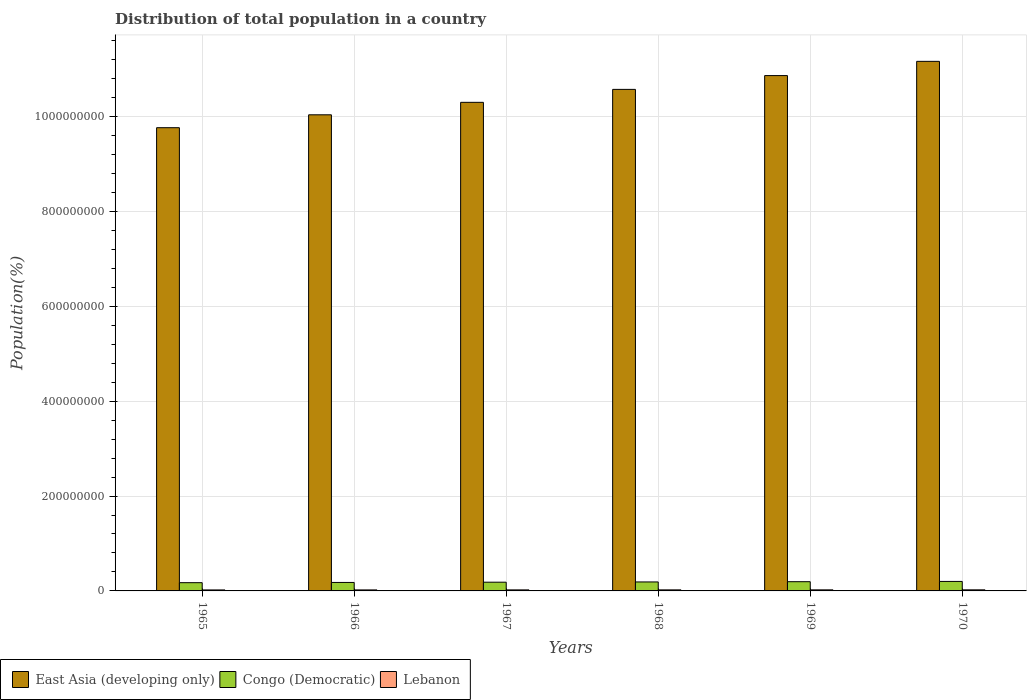How many different coloured bars are there?
Your response must be concise. 3. How many groups of bars are there?
Your answer should be very brief. 6. How many bars are there on the 6th tick from the right?
Your answer should be compact. 3. What is the label of the 4th group of bars from the left?
Give a very brief answer. 1968. In how many cases, is the number of bars for a given year not equal to the number of legend labels?
Provide a succinct answer. 0. What is the population of in Lebanon in 1966?
Your answer should be very brief. 2.14e+06. Across all years, what is the maximum population of in East Asia (developing only)?
Offer a terse response. 1.12e+09. Across all years, what is the minimum population of in Lebanon?
Your answer should be very brief. 2.09e+06. In which year was the population of in East Asia (developing only) minimum?
Your answer should be very brief. 1965. What is the total population of in Congo (Democratic) in the graph?
Ensure brevity in your answer.  1.12e+08. What is the difference between the population of in Congo (Democratic) in 1965 and that in 1967?
Offer a very short reply. -1.01e+06. What is the difference between the population of in Lebanon in 1966 and the population of in Congo (Democratic) in 1970?
Offer a terse response. -1.79e+07. What is the average population of in Lebanon per year?
Your answer should be very brief. 2.19e+06. In the year 1967, what is the difference between the population of in Lebanon and population of in Congo (Democratic)?
Your answer should be compact. -1.62e+07. What is the ratio of the population of in Congo (Democratic) in 1965 to that in 1967?
Offer a terse response. 0.95. What is the difference between the highest and the second highest population of in Congo (Democratic)?
Offer a terse response. 5.51e+05. What is the difference between the highest and the lowest population of in East Asia (developing only)?
Keep it short and to the point. 1.40e+08. In how many years, is the population of in East Asia (developing only) greater than the average population of in East Asia (developing only) taken over all years?
Provide a short and direct response. 3. What does the 2nd bar from the left in 1966 represents?
Your response must be concise. Congo (Democratic). What does the 1st bar from the right in 1967 represents?
Your answer should be compact. Lebanon. Are all the bars in the graph horizontal?
Make the answer very short. No. How many years are there in the graph?
Make the answer very short. 6. What is the difference between two consecutive major ticks on the Y-axis?
Your response must be concise. 2.00e+08. Does the graph contain any zero values?
Keep it short and to the point. No. Where does the legend appear in the graph?
Give a very brief answer. Bottom left. What is the title of the graph?
Your answer should be very brief. Distribution of total population in a country. What is the label or title of the X-axis?
Your response must be concise. Years. What is the label or title of the Y-axis?
Keep it short and to the point. Population(%). What is the Population(%) of East Asia (developing only) in 1965?
Provide a short and direct response. 9.76e+08. What is the Population(%) in Congo (Democratic) in 1965?
Ensure brevity in your answer.  1.74e+07. What is the Population(%) of Lebanon in 1965?
Your response must be concise. 2.09e+06. What is the Population(%) of East Asia (developing only) in 1966?
Offer a terse response. 1.00e+09. What is the Population(%) of Congo (Democratic) in 1966?
Ensure brevity in your answer.  1.79e+07. What is the Population(%) of Lebanon in 1966?
Give a very brief answer. 2.14e+06. What is the Population(%) of East Asia (developing only) in 1967?
Your answer should be very brief. 1.03e+09. What is the Population(%) of Congo (Democratic) in 1967?
Your answer should be very brief. 1.84e+07. What is the Population(%) of Lebanon in 1967?
Your answer should be very brief. 2.17e+06. What is the Population(%) of East Asia (developing only) in 1968?
Provide a short and direct response. 1.06e+09. What is the Population(%) of Congo (Democratic) in 1968?
Your response must be concise. 1.89e+07. What is the Population(%) of Lebanon in 1968?
Your answer should be compact. 2.21e+06. What is the Population(%) in East Asia (developing only) in 1969?
Provide a succinct answer. 1.09e+09. What is the Population(%) of Congo (Democratic) in 1969?
Offer a terse response. 1.95e+07. What is the Population(%) in Lebanon in 1969?
Your response must be concise. 2.25e+06. What is the Population(%) in East Asia (developing only) in 1970?
Ensure brevity in your answer.  1.12e+09. What is the Population(%) of Congo (Democratic) in 1970?
Provide a succinct answer. 2.00e+07. What is the Population(%) of Lebanon in 1970?
Keep it short and to the point. 2.30e+06. Across all years, what is the maximum Population(%) of East Asia (developing only)?
Provide a short and direct response. 1.12e+09. Across all years, what is the maximum Population(%) in Congo (Democratic)?
Offer a terse response. 2.00e+07. Across all years, what is the maximum Population(%) in Lebanon?
Provide a short and direct response. 2.30e+06. Across all years, what is the minimum Population(%) of East Asia (developing only)?
Ensure brevity in your answer.  9.76e+08. Across all years, what is the minimum Population(%) of Congo (Democratic)?
Ensure brevity in your answer.  1.74e+07. Across all years, what is the minimum Population(%) in Lebanon?
Offer a very short reply. 2.09e+06. What is the total Population(%) of East Asia (developing only) in the graph?
Your answer should be very brief. 6.27e+09. What is the total Population(%) of Congo (Democratic) in the graph?
Make the answer very short. 1.12e+08. What is the total Population(%) in Lebanon in the graph?
Your response must be concise. 1.32e+07. What is the difference between the Population(%) in East Asia (developing only) in 1965 and that in 1966?
Make the answer very short. -2.72e+07. What is the difference between the Population(%) in Congo (Democratic) in 1965 and that in 1966?
Make the answer very short. -4.92e+05. What is the difference between the Population(%) in Lebanon in 1965 and that in 1966?
Your answer should be compact. -4.43e+04. What is the difference between the Population(%) of East Asia (developing only) in 1965 and that in 1967?
Provide a succinct answer. -5.35e+07. What is the difference between the Population(%) in Congo (Democratic) in 1965 and that in 1967?
Offer a very short reply. -1.01e+06. What is the difference between the Population(%) in Lebanon in 1965 and that in 1967?
Give a very brief answer. -8.25e+04. What is the difference between the Population(%) of East Asia (developing only) in 1965 and that in 1968?
Give a very brief answer. -8.08e+07. What is the difference between the Population(%) in Congo (Democratic) in 1965 and that in 1968?
Your answer should be compact. -1.54e+06. What is the difference between the Population(%) of Lebanon in 1965 and that in 1968?
Your answer should be very brief. -1.19e+05. What is the difference between the Population(%) in East Asia (developing only) in 1965 and that in 1969?
Provide a short and direct response. -1.10e+08. What is the difference between the Population(%) of Congo (Democratic) in 1965 and that in 1969?
Make the answer very short. -2.09e+06. What is the difference between the Population(%) in Lebanon in 1965 and that in 1969?
Ensure brevity in your answer.  -1.58e+05. What is the difference between the Population(%) of East Asia (developing only) in 1965 and that in 1970?
Offer a very short reply. -1.40e+08. What is the difference between the Population(%) in Congo (Democratic) in 1965 and that in 1970?
Provide a short and direct response. -2.64e+06. What is the difference between the Population(%) in Lebanon in 1965 and that in 1970?
Give a very brief answer. -2.05e+05. What is the difference between the Population(%) of East Asia (developing only) in 1966 and that in 1967?
Your answer should be very brief. -2.63e+07. What is the difference between the Population(%) of Congo (Democratic) in 1966 and that in 1967?
Make the answer very short. -5.16e+05. What is the difference between the Population(%) in Lebanon in 1966 and that in 1967?
Ensure brevity in your answer.  -3.82e+04. What is the difference between the Population(%) of East Asia (developing only) in 1966 and that in 1968?
Make the answer very short. -5.36e+07. What is the difference between the Population(%) of Congo (Democratic) in 1966 and that in 1968?
Your answer should be very brief. -1.05e+06. What is the difference between the Population(%) of Lebanon in 1966 and that in 1968?
Give a very brief answer. -7.43e+04. What is the difference between the Population(%) in East Asia (developing only) in 1966 and that in 1969?
Keep it short and to the point. -8.27e+07. What is the difference between the Population(%) in Congo (Democratic) in 1966 and that in 1969?
Your answer should be very brief. -1.60e+06. What is the difference between the Population(%) in Lebanon in 1966 and that in 1969?
Provide a succinct answer. -1.14e+05. What is the difference between the Population(%) in East Asia (developing only) in 1966 and that in 1970?
Offer a terse response. -1.13e+08. What is the difference between the Population(%) of Congo (Democratic) in 1966 and that in 1970?
Make the answer very short. -2.15e+06. What is the difference between the Population(%) of Lebanon in 1966 and that in 1970?
Offer a very short reply. -1.61e+05. What is the difference between the Population(%) in East Asia (developing only) in 1967 and that in 1968?
Provide a succinct answer. -2.73e+07. What is the difference between the Population(%) of Congo (Democratic) in 1967 and that in 1968?
Offer a terse response. -5.35e+05. What is the difference between the Population(%) of Lebanon in 1967 and that in 1968?
Offer a terse response. -3.61e+04. What is the difference between the Population(%) in East Asia (developing only) in 1967 and that in 1969?
Provide a succinct answer. -5.64e+07. What is the difference between the Population(%) in Congo (Democratic) in 1967 and that in 1969?
Offer a terse response. -1.08e+06. What is the difference between the Population(%) of Lebanon in 1967 and that in 1969?
Ensure brevity in your answer.  -7.58e+04. What is the difference between the Population(%) of East Asia (developing only) in 1967 and that in 1970?
Offer a terse response. -8.64e+07. What is the difference between the Population(%) in Congo (Democratic) in 1967 and that in 1970?
Ensure brevity in your answer.  -1.63e+06. What is the difference between the Population(%) in Lebanon in 1967 and that in 1970?
Your response must be concise. -1.23e+05. What is the difference between the Population(%) of East Asia (developing only) in 1968 and that in 1969?
Give a very brief answer. -2.91e+07. What is the difference between the Population(%) in Congo (Democratic) in 1968 and that in 1969?
Provide a short and direct response. -5.46e+05. What is the difference between the Population(%) of Lebanon in 1968 and that in 1969?
Ensure brevity in your answer.  -3.96e+04. What is the difference between the Population(%) of East Asia (developing only) in 1968 and that in 1970?
Your answer should be compact. -5.91e+07. What is the difference between the Population(%) of Congo (Democratic) in 1968 and that in 1970?
Ensure brevity in your answer.  -1.10e+06. What is the difference between the Population(%) of Lebanon in 1968 and that in 1970?
Offer a very short reply. -8.64e+04. What is the difference between the Population(%) in East Asia (developing only) in 1969 and that in 1970?
Offer a very short reply. -3.00e+07. What is the difference between the Population(%) of Congo (Democratic) in 1969 and that in 1970?
Ensure brevity in your answer.  -5.51e+05. What is the difference between the Population(%) in Lebanon in 1969 and that in 1970?
Offer a terse response. -4.68e+04. What is the difference between the Population(%) in East Asia (developing only) in 1965 and the Population(%) in Congo (Democratic) in 1966?
Your response must be concise. 9.59e+08. What is the difference between the Population(%) in East Asia (developing only) in 1965 and the Population(%) in Lebanon in 1966?
Give a very brief answer. 9.74e+08. What is the difference between the Population(%) of Congo (Democratic) in 1965 and the Population(%) of Lebanon in 1966?
Ensure brevity in your answer.  1.52e+07. What is the difference between the Population(%) of East Asia (developing only) in 1965 and the Population(%) of Congo (Democratic) in 1967?
Provide a succinct answer. 9.58e+08. What is the difference between the Population(%) of East Asia (developing only) in 1965 and the Population(%) of Lebanon in 1967?
Give a very brief answer. 9.74e+08. What is the difference between the Population(%) of Congo (Democratic) in 1965 and the Population(%) of Lebanon in 1967?
Make the answer very short. 1.52e+07. What is the difference between the Population(%) in East Asia (developing only) in 1965 and the Population(%) in Congo (Democratic) in 1968?
Provide a succinct answer. 9.57e+08. What is the difference between the Population(%) of East Asia (developing only) in 1965 and the Population(%) of Lebanon in 1968?
Give a very brief answer. 9.74e+08. What is the difference between the Population(%) of Congo (Democratic) in 1965 and the Population(%) of Lebanon in 1968?
Your answer should be very brief. 1.52e+07. What is the difference between the Population(%) in East Asia (developing only) in 1965 and the Population(%) in Congo (Democratic) in 1969?
Offer a terse response. 9.57e+08. What is the difference between the Population(%) of East Asia (developing only) in 1965 and the Population(%) of Lebanon in 1969?
Keep it short and to the point. 9.74e+08. What is the difference between the Population(%) in Congo (Democratic) in 1965 and the Population(%) in Lebanon in 1969?
Your response must be concise. 1.51e+07. What is the difference between the Population(%) in East Asia (developing only) in 1965 and the Population(%) in Congo (Democratic) in 1970?
Offer a very short reply. 9.56e+08. What is the difference between the Population(%) in East Asia (developing only) in 1965 and the Population(%) in Lebanon in 1970?
Your response must be concise. 9.74e+08. What is the difference between the Population(%) of Congo (Democratic) in 1965 and the Population(%) of Lebanon in 1970?
Your answer should be compact. 1.51e+07. What is the difference between the Population(%) of East Asia (developing only) in 1966 and the Population(%) of Congo (Democratic) in 1967?
Your answer should be compact. 9.85e+08. What is the difference between the Population(%) in East Asia (developing only) in 1966 and the Population(%) in Lebanon in 1967?
Give a very brief answer. 1.00e+09. What is the difference between the Population(%) of Congo (Democratic) in 1966 and the Population(%) of Lebanon in 1967?
Provide a succinct answer. 1.57e+07. What is the difference between the Population(%) in East Asia (developing only) in 1966 and the Population(%) in Congo (Democratic) in 1968?
Make the answer very short. 9.85e+08. What is the difference between the Population(%) of East Asia (developing only) in 1966 and the Population(%) of Lebanon in 1968?
Make the answer very short. 1.00e+09. What is the difference between the Population(%) of Congo (Democratic) in 1966 and the Population(%) of Lebanon in 1968?
Ensure brevity in your answer.  1.57e+07. What is the difference between the Population(%) in East Asia (developing only) in 1966 and the Population(%) in Congo (Democratic) in 1969?
Provide a short and direct response. 9.84e+08. What is the difference between the Population(%) in East Asia (developing only) in 1966 and the Population(%) in Lebanon in 1969?
Your answer should be compact. 1.00e+09. What is the difference between the Population(%) in Congo (Democratic) in 1966 and the Population(%) in Lebanon in 1969?
Offer a terse response. 1.56e+07. What is the difference between the Population(%) of East Asia (developing only) in 1966 and the Population(%) of Congo (Democratic) in 1970?
Provide a succinct answer. 9.84e+08. What is the difference between the Population(%) in East Asia (developing only) in 1966 and the Population(%) in Lebanon in 1970?
Offer a terse response. 1.00e+09. What is the difference between the Population(%) of Congo (Democratic) in 1966 and the Population(%) of Lebanon in 1970?
Offer a terse response. 1.56e+07. What is the difference between the Population(%) of East Asia (developing only) in 1967 and the Population(%) of Congo (Democratic) in 1968?
Give a very brief answer. 1.01e+09. What is the difference between the Population(%) in East Asia (developing only) in 1967 and the Population(%) in Lebanon in 1968?
Keep it short and to the point. 1.03e+09. What is the difference between the Population(%) in Congo (Democratic) in 1967 and the Population(%) in Lebanon in 1968?
Make the answer very short. 1.62e+07. What is the difference between the Population(%) of East Asia (developing only) in 1967 and the Population(%) of Congo (Democratic) in 1969?
Provide a succinct answer. 1.01e+09. What is the difference between the Population(%) in East Asia (developing only) in 1967 and the Population(%) in Lebanon in 1969?
Make the answer very short. 1.03e+09. What is the difference between the Population(%) of Congo (Democratic) in 1967 and the Population(%) of Lebanon in 1969?
Keep it short and to the point. 1.61e+07. What is the difference between the Population(%) in East Asia (developing only) in 1967 and the Population(%) in Congo (Democratic) in 1970?
Ensure brevity in your answer.  1.01e+09. What is the difference between the Population(%) of East Asia (developing only) in 1967 and the Population(%) of Lebanon in 1970?
Provide a short and direct response. 1.03e+09. What is the difference between the Population(%) of Congo (Democratic) in 1967 and the Population(%) of Lebanon in 1970?
Keep it short and to the point. 1.61e+07. What is the difference between the Population(%) in East Asia (developing only) in 1968 and the Population(%) in Congo (Democratic) in 1969?
Keep it short and to the point. 1.04e+09. What is the difference between the Population(%) of East Asia (developing only) in 1968 and the Population(%) of Lebanon in 1969?
Your response must be concise. 1.05e+09. What is the difference between the Population(%) in Congo (Democratic) in 1968 and the Population(%) in Lebanon in 1969?
Offer a very short reply. 1.67e+07. What is the difference between the Population(%) of East Asia (developing only) in 1968 and the Population(%) of Congo (Democratic) in 1970?
Offer a very short reply. 1.04e+09. What is the difference between the Population(%) in East Asia (developing only) in 1968 and the Population(%) in Lebanon in 1970?
Offer a very short reply. 1.05e+09. What is the difference between the Population(%) in Congo (Democratic) in 1968 and the Population(%) in Lebanon in 1970?
Keep it short and to the point. 1.66e+07. What is the difference between the Population(%) of East Asia (developing only) in 1969 and the Population(%) of Congo (Democratic) in 1970?
Offer a terse response. 1.07e+09. What is the difference between the Population(%) in East Asia (developing only) in 1969 and the Population(%) in Lebanon in 1970?
Keep it short and to the point. 1.08e+09. What is the difference between the Population(%) of Congo (Democratic) in 1969 and the Population(%) of Lebanon in 1970?
Offer a very short reply. 1.72e+07. What is the average Population(%) in East Asia (developing only) per year?
Offer a terse response. 1.04e+09. What is the average Population(%) in Congo (Democratic) per year?
Keep it short and to the point. 1.87e+07. What is the average Population(%) in Lebanon per year?
Your answer should be very brief. 2.19e+06. In the year 1965, what is the difference between the Population(%) in East Asia (developing only) and Population(%) in Congo (Democratic)?
Offer a terse response. 9.59e+08. In the year 1965, what is the difference between the Population(%) in East Asia (developing only) and Population(%) in Lebanon?
Your response must be concise. 9.74e+08. In the year 1965, what is the difference between the Population(%) of Congo (Democratic) and Population(%) of Lebanon?
Provide a short and direct response. 1.53e+07. In the year 1966, what is the difference between the Population(%) of East Asia (developing only) and Population(%) of Congo (Democratic)?
Your response must be concise. 9.86e+08. In the year 1966, what is the difference between the Population(%) in East Asia (developing only) and Population(%) in Lebanon?
Make the answer very short. 1.00e+09. In the year 1966, what is the difference between the Population(%) of Congo (Democratic) and Population(%) of Lebanon?
Offer a terse response. 1.57e+07. In the year 1967, what is the difference between the Population(%) in East Asia (developing only) and Population(%) in Congo (Democratic)?
Give a very brief answer. 1.01e+09. In the year 1967, what is the difference between the Population(%) of East Asia (developing only) and Population(%) of Lebanon?
Provide a succinct answer. 1.03e+09. In the year 1967, what is the difference between the Population(%) in Congo (Democratic) and Population(%) in Lebanon?
Keep it short and to the point. 1.62e+07. In the year 1968, what is the difference between the Population(%) in East Asia (developing only) and Population(%) in Congo (Democratic)?
Provide a short and direct response. 1.04e+09. In the year 1968, what is the difference between the Population(%) in East Asia (developing only) and Population(%) in Lebanon?
Your answer should be very brief. 1.05e+09. In the year 1968, what is the difference between the Population(%) of Congo (Democratic) and Population(%) of Lebanon?
Provide a succinct answer. 1.67e+07. In the year 1969, what is the difference between the Population(%) of East Asia (developing only) and Population(%) of Congo (Democratic)?
Ensure brevity in your answer.  1.07e+09. In the year 1969, what is the difference between the Population(%) of East Asia (developing only) and Population(%) of Lebanon?
Give a very brief answer. 1.08e+09. In the year 1969, what is the difference between the Population(%) in Congo (Democratic) and Population(%) in Lebanon?
Make the answer very short. 1.72e+07. In the year 1970, what is the difference between the Population(%) in East Asia (developing only) and Population(%) in Congo (Democratic)?
Offer a very short reply. 1.10e+09. In the year 1970, what is the difference between the Population(%) in East Asia (developing only) and Population(%) in Lebanon?
Provide a short and direct response. 1.11e+09. In the year 1970, what is the difference between the Population(%) in Congo (Democratic) and Population(%) in Lebanon?
Ensure brevity in your answer.  1.77e+07. What is the ratio of the Population(%) of East Asia (developing only) in 1965 to that in 1966?
Make the answer very short. 0.97. What is the ratio of the Population(%) of Congo (Democratic) in 1965 to that in 1966?
Your answer should be very brief. 0.97. What is the ratio of the Population(%) in Lebanon in 1965 to that in 1966?
Your response must be concise. 0.98. What is the ratio of the Population(%) of East Asia (developing only) in 1965 to that in 1967?
Your response must be concise. 0.95. What is the ratio of the Population(%) of Congo (Democratic) in 1965 to that in 1967?
Give a very brief answer. 0.95. What is the ratio of the Population(%) in Lebanon in 1965 to that in 1967?
Ensure brevity in your answer.  0.96. What is the ratio of the Population(%) of East Asia (developing only) in 1965 to that in 1968?
Your answer should be compact. 0.92. What is the ratio of the Population(%) of Congo (Democratic) in 1965 to that in 1968?
Your response must be concise. 0.92. What is the ratio of the Population(%) of Lebanon in 1965 to that in 1968?
Offer a terse response. 0.95. What is the ratio of the Population(%) in East Asia (developing only) in 1965 to that in 1969?
Give a very brief answer. 0.9. What is the ratio of the Population(%) in Congo (Democratic) in 1965 to that in 1969?
Give a very brief answer. 0.89. What is the ratio of the Population(%) in Lebanon in 1965 to that in 1969?
Make the answer very short. 0.93. What is the ratio of the Population(%) in East Asia (developing only) in 1965 to that in 1970?
Offer a terse response. 0.87. What is the ratio of the Population(%) of Congo (Democratic) in 1965 to that in 1970?
Keep it short and to the point. 0.87. What is the ratio of the Population(%) of Lebanon in 1965 to that in 1970?
Give a very brief answer. 0.91. What is the ratio of the Population(%) of East Asia (developing only) in 1966 to that in 1967?
Make the answer very short. 0.97. What is the ratio of the Population(%) in Congo (Democratic) in 1966 to that in 1967?
Offer a very short reply. 0.97. What is the ratio of the Population(%) of Lebanon in 1966 to that in 1967?
Give a very brief answer. 0.98. What is the ratio of the Population(%) in East Asia (developing only) in 1966 to that in 1968?
Give a very brief answer. 0.95. What is the ratio of the Population(%) in Congo (Democratic) in 1966 to that in 1968?
Offer a terse response. 0.94. What is the ratio of the Population(%) of Lebanon in 1966 to that in 1968?
Offer a terse response. 0.97. What is the ratio of the Population(%) in East Asia (developing only) in 1966 to that in 1969?
Give a very brief answer. 0.92. What is the ratio of the Population(%) in Congo (Democratic) in 1966 to that in 1969?
Make the answer very short. 0.92. What is the ratio of the Population(%) of Lebanon in 1966 to that in 1969?
Provide a succinct answer. 0.95. What is the ratio of the Population(%) of East Asia (developing only) in 1966 to that in 1970?
Offer a very short reply. 0.9. What is the ratio of the Population(%) in Congo (Democratic) in 1966 to that in 1970?
Provide a short and direct response. 0.89. What is the ratio of the Population(%) in Lebanon in 1966 to that in 1970?
Ensure brevity in your answer.  0.93. What is the ratio of the Population(%) of East Asia (developing only) in 1967 to that in 1968?
Give a very brief answer. 0.97. What is the ratio of the Population(%) of Congo (Democratic) in 1967 to that in 1968?
Your response must be concise. 0.97. What is the ratio of the Population(%) in Lebanon in 1967 to that in 1968?
Provide a succinct answer. 0.98. What is the ratio of the Population(%) in East Asia (developing only) in 1967 to that in 1969?
Offer a terse response. 0.95. What is the ratio of the Population(%) in Congo (Democratic) in 1967 to that in 1969?
Provide a succinct answer. 0.94. What is the ratio of the Population(%) of Lebanon in 1967 to that in 1969?
Your answer should be compact. 0.97. What is the ratio of the Population(%) in East Asia (developing only) in 1967 to that in 1970?
Give a very brief answer. 0.92. What is the ratio of the Population(%) in Congo (Democratic) in 1967 to that in 1970?
Your answer should be compact. 0.92. What is the ratio of the Population(%) in Lebanon in 1967 to that in 1970?
Offer a very short reply. 0.95. What is the ratio of the Population(%) in East Asia (developing only) in 1968 to that in 1969?
Offer a very short reply. 0.97. What is the ratio of the Population(%) in Lebanon in 1968 to that in 1969?
Your answer should be very brief. 0.98. What is the ratio of the Population(%) in East Asia (developing only) in 1968 to that in 1970?
Your answer should be very brief. 0.95. What is the ratio of the Population(%) of Congo (Democratic) in 1968 to that in 1970?
Provide a succinct answer. 0.95. What is the ratio of the Population(%) of Lebanon in 1968 to that in 1970?
Ensure brevity in your answer.  0.96. What is the ratio of the Population(%) of East Asia (developing only) in 1969 to that in 1970?
Your response must be concise. 0.97. What is the ratio of the Population(%) of Congo (Democratic) in 1969 to that in 1970?
Ensure brevity in your answer.  0.97. What is the ratio of the Population(%) in Lebanon in 1969 to that in 1970?
Provide a short and direct response. 0.98. What is the difference between the highest and the second highest Population(%) of East Asia (developing only)?
Provide a succinct answer. 3.00e+07. What is the difference between the highest and the second highest Population(%) of Congo (Democratic)?
Your answer should be very brief. 5.51e+05. What is the difference between the highest and the second highest Population(%) of Lebanon?
Provide a succinct answer. 4.68e+04. What is the difference between the highest and the lowest Population(%) of East Asia (developing only)?
Make the answer very short. 1.40e+08. What is the difference between the highest and the lowest Population(%) of Congo (Democratic)?
Offer a very short reply. 2.64e+06. What is the difference between the highest and the lowest Population(%) in Lebanon?
Offer a very short reply. 2.05e+05. 